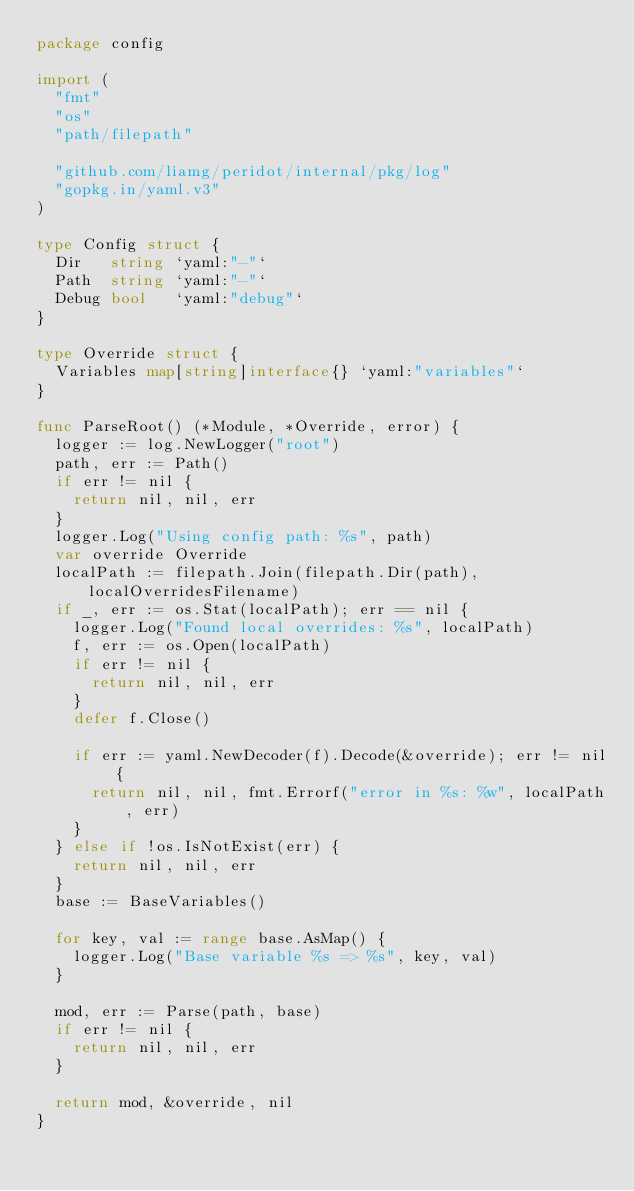Convert code to text. <code><loc_0><loc_0><loc_500><loc_500><_Go_>package config

import (
	"fmt"
	"os"
	"path/filepath"

	"github.com/liamg/peridot/internal/pkg/log"
	"gopkg.in/yaml.v3"
)

type Config struct {
	Dir   string `yaml:"-"`
	Path  string `yaml:"-"`
	Debug bool   `yaml:"debug"`
}

type Override struct {
	Variables map[string]interface{} `yaml:"variables"`
}

func ParseRoot() (*Module, *Override, error) {
	logger := log.NewLogger("root")
	path, err := Path()
	if err != nil {
		return nil, nil, err
	}
	logger.Log("Using config path: %s", path)
	var override Override
	localPath := filepath.Join(filepath.Dir(path), localOverridesFilename)
	if _, err := os.Stat(localPath); err == nil {
		logger.Log("Found local overrides: %s", localPath)
		f, err := os.Open(localPath)
		if err != nil {
			return nil, nil, err
		}
		defer f.Close()

		if err := yaml.NewDecoder(f).Decode(&override); err != nil {
			return nil, nil, fmt.Errorf("error in %s: %w", localPath, err)
		}
	} else if !os.IsNotExist(err) {
		return nil, nil, err
	}
	base := BaseVariables()

	for key, val := range base.AsMap() {
		logger.Log("Base variable %s => %s", key, val)
	}

	mod, err := Parse(path, base)
	if err != nil {
		return nil, nil, err
	}

	return mod, &override, nil
}
</code> 